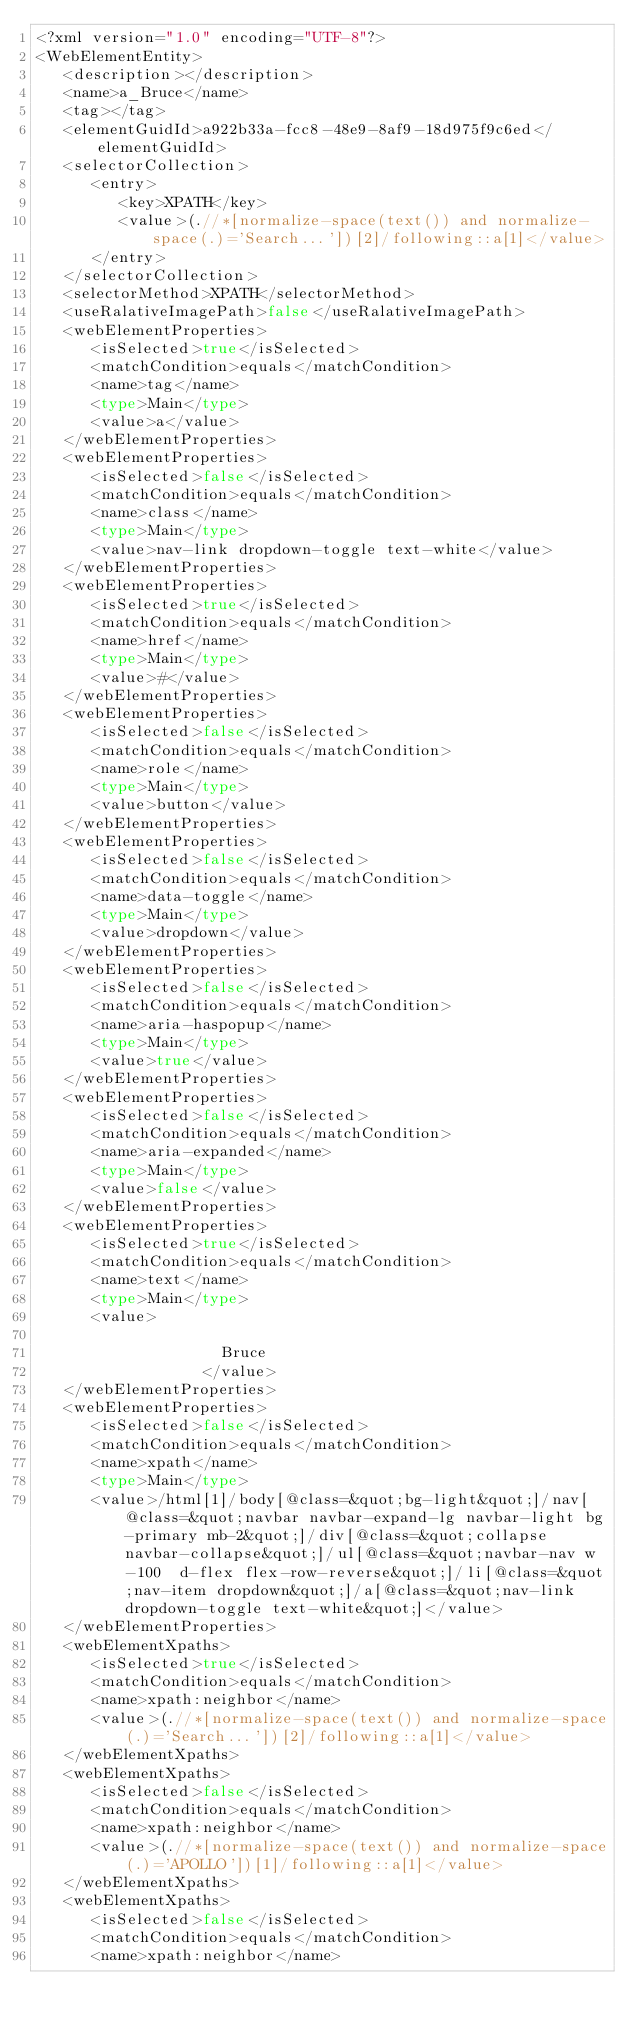<code> <loc_0><loc_0><loc_500><loc_500><_Rust_><?xml version="1.0" encoding="UTF-8"?>
<WebElementEntity>
   <description></description>
   <name>a_Bruce</name>
   <tag></tag>
   <elementGuidId>a922b33a-fcc8-48e9-8af9-18d975f9c6ed</elementGuidId>
   <selectorCollection>
      <entry>
         <key>XPATH</key>
         <value>(.//*[normalize-space(text()) and normalize-space(.)='Search...'])[2]/following::a[1]</value>
      </entry>
   </selectorCollection>
   <selectorMethod>XPATH</selectorMethod>
   <useRalativeImagePath>false</useRalativeImagePath>
   <webElementProperties>
      <isSelected>true</isSelected>
      <matchCondition>equals</matchCondition>
      <name>tag</name>
      <type>Main</type>
      <value>a</value>
   </webElementProperties>
   <webElementProperties>
      <isSelected>false</isSelected>
      <matchCondition>equals</matchCondition>
      <name>class</name>
      <type>Main</type>
      <value>nav-link dropdown-toggle text-white</value>
   </webElementProperties>
   <webElementProperties>
      <isSelected>true</isSelected>
      <matchCondition>equals</matchCondition>
      <name>href</name>
      <type>Main</type>
      <value>#</value>
   </webElementProperties>
   <webElementProperties>
      <isSelected>false</isSelected>
      <matchCondition>equals</matchCondition>
      <name>role</name>
      <type>Main</type>
      <value>button</value>
   </webElementProperties>
   <webElementProperties>
      <isSelected>false</isSelected>
      <matchCondition>equals</matchCondition>
      <name>data-toggle</name>
      <type>Main</type>
      <value>dropdown</value>
   </webElementProperties>
   <webElementProperties>
      <isSelected>false</isSelected>
      <matchCondition>equals</matchCondition>
      <name>aria-haspopup</name>
      <type>Main</type>
      <value>true</value>
   </webElementProperties>
   <webElementProperties>
      <isSelected>false</isSelected>
      <matchCondition>equals</matchCondition>
      <name>aria-expanded</name>
      <type>Main</type>
      <value>false</value>
   </webElementProperties>
   <webElementProperties>
      <isSelected>true</isSelected>
      <matchCondition>equals</matchCondition>
      <name>text</name>
      <type>Main</type>
      <value>
                    
                    Bruce
                  </value>
   </webElementProperties>
   <webElementProperties>
      <isSelected>false</isSelected>
      <matchCondition>equals</matchCondition>
      <name>xpath</name>
      <type>Main</type>
      <value>/html[1]/body[@class=&quot;bg-light&quot;]/nav[@class=&quot;navbar navbar-expand-lg navbar-light bg-primary mb-2&quot;]/div[@class=&quot;collapse navbar-collapse&quot;]/ul[@class=&quot;navbar-nav w-100  d-flex flex-row-reverse&quot;]/li[@class=&quot;nav-item dropdown&quot;]/a[@class=&quot;nav-link dropdown-toggle text-white&quot;]</value>
   </webElementProperties>
   <webElementXpaths>
      <isSelected>true</isSelected>
      <matchCondition>equals</matchCondition>
      <name>xpath:neighbor</name>
      <value>(.//*[normalize-space(text()) and normalize-space(.)='Search...'])[2]/following::a[1]</value>
   </webElementXpaths>
   <webElementXpaths>
      <isSelected>false</isSelected>
      <matchCondition>equals</matchCondition>
      <name>xpath:neighbor</name>
      <value>(.//*[normalize-space(text()) and normalize-space(.)='APOLLO'])[1]/following::a[1]</value>
   </webElementXpaths>
   <webElementXpaths>
      <isSelected>false</isSelected>
      <matchCondition>equals</matchCondition>
      <name>xpath:neighbor</name></code> 